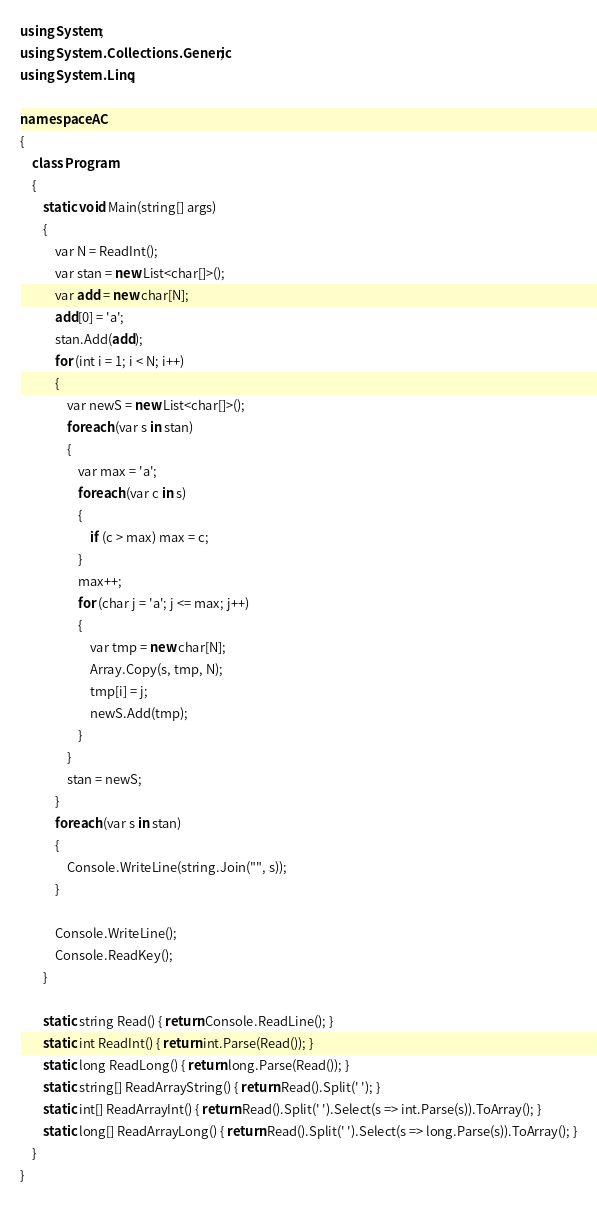<code> <loc_0><loc_0><loc_500><loc_500><_C#_>using System;
using System.Collections.Generic;
using System.Linq;

namespace AC
{
    class Program
    {
        static void Main(string[] args)
        {
            var N = ReadInt();
            var stan = new List<char[]>();
            var add = new char[N];
            add[0] = 'a';
            stan.Add(add);
            for (int i = 1; i < N; i++)
            {
                var newS = new List<char[]>();
                foreach (var s in stan)
                {
                    var max = 'a';
                    foreach (var c in s)
                    {
                        if (c > max) max = c;
                    }
                    max++;
                    for (char j = 'a'; j <= max; j++)
                    {
                        var tmp = new char[N];
                        Array.Copy(s, tmp, N);
                        tmp[i] = j;
                        newS.Add(tmp);
                    }
                }
                stan = newS;
            }
            foreach (var s in stan)
            {
                Console.WriteLine(string.Join("", s));
            }

            Console.WriteLine();
            Console.ReadKey();
        }

        static string Read() { return Console.ReadLine(); }
        static int ReadInt() { return int.Parse(Read()); }
        static long ReadLong() { return long.Parse(Read()); }
        static string[] ReadArrayString() { return Read().Split(' '); }
        static int[] ReadArrayInt() { return Read().Split(' ').Select(s => int.Parse(s)).ToArray(); }
        static long[] ReadArrayLong() { return Read().Split(' ').Select(s => long.Parse(s)).ToArray(); }
    }
}</code> 